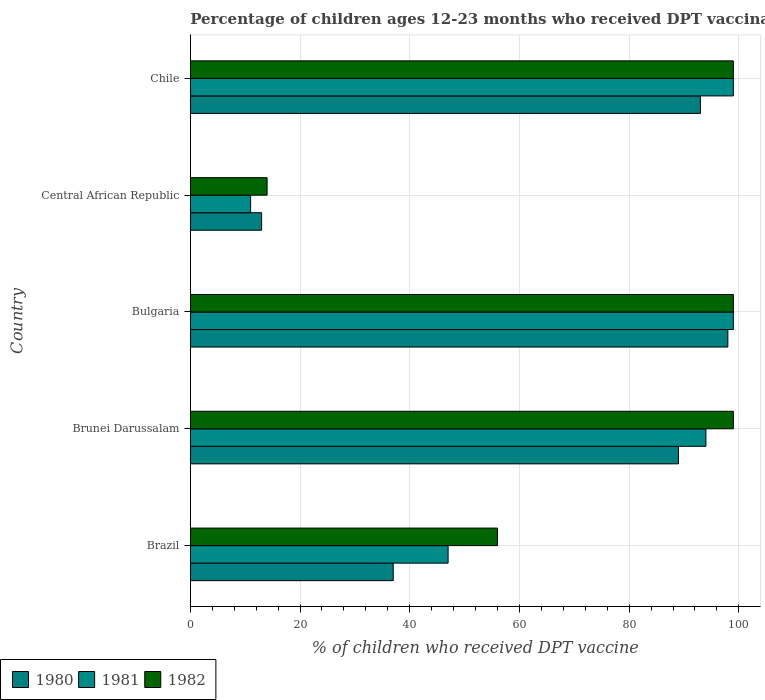How many groups of bars are there?
Give a very brief answer. 5. Are the number of bars per tick equal to the number of legend labels?
Ensure brevity in your answer.  Yes. Are the number of bars on each tick of the Y-axis equal?
Provide a succinct answer. Yes. What is the label of the 3rd group of bars from the top?
Your answer should be compact. Bulgaria. In how many cases, is the number of bars for a given country not equal to the number of legend labels?
Your answer should be very brief. 0. Across all countries, what is the maximum percentage of children who received DPT vaccination in 1981?
Offer a very short reply. 99. Across all countries, what is the minimum percentage of children who received DPT vaccination in 1980?
Keep it short and to the point. 13. In which country was the percentage of children who received DPT vaccination in 1981 minimum?
Offer a terse response. Central African Republic. What is the total percentage of children who received DPT vaccination in 1980 in the graph?
Make the answer very short. 330. What is the difference between the percentage of children who received DPT vaccination in 1982 in Brazil and that in Chile?
Give a very brief answer. -43. What is the average percentage of children who received DPT vaccination in 1981 per country?
Offer a very short reply. 70. Is the difference between the percentage of children who received DPT vaccination in 1982 in Bulgaria and Central African Republic greater than the difference between the percentage of children who received DPT vaccination in 1981 in Bulgaria and Central African Republic?
Your response must be concise. No. What does the 3rd bar from the top in Chile represents?
Provide a succinct answer. 1980. What does the 1st bar from the bottom in Bulgaria represents?
Your answer should be compact. 1980. Is it the case that in every country, the sum of the percentage of children who received DPT vaccination in 1982 and percentage of children who received DPT vaccination in 1981 is greater than the percentage of children who received DPT vaccination in 1980?
Ensure brevity in your answer.  Yes. Where does the legend appear in the graph?
Your answer should be compact. Bottom left. What is the title of the graph?
Your answer should be compact. Percentage of children ages 12-23 months who received DPT vaccinations. What is the label or title of the X-axis?
Give a very brief answer. % of children who received DPT vaccine. What is the label or title of the Y-axis?
Your answer should be compact. Country. What is the % of children who received DPT vaccine in 1980 in Brazil?
Offer a terse response. 37. What is the % of children who received DPT vaccine of 1981 in Brazil?
Give a very brief answer. 47. What is the % of children who received DPT vaccine of 1982 in Brazil?
Your answer should be compact. 56. What is the % of children who received DPT vaccine of 1980 in Brunei Darussalam?
Make the answer very short. 89. What is the % of children who received DPT vaccine in 1981 in Brunei Darussalam?
Give a very brief answer. 94. What is the % of children who received DPT vaccine in 1982 in Brunei Darussalam?
Ensure brevity in your answer.  99. What is the % of children who received DPT vaccine of 1980 in Bulgaria?
Offer a very short reply. 98. What is the % of children who received DPT vaccine of 1981 in Bulgaria?
Provide a succinct answer. 99. What is the % of children who received DPT vaccine in 1980 in Central African Republic?
Provide a short and direct response. 13. What is the % of children who received DPT vaccine of 1981 in Central African Republic?
Offer a very short reply. 11. What is the % of children who received DPT vaccine of 1980 in Chile?
Provide a succinct answer. 93. What is the % of children who received DPT vaccine in 1981 in Chile?
Your answer should be compact. 99. Across all countries, what is the maximum % of children who received DPT vaccine in 1981?
Offer a very short reply. 99. Across all countries, what is the minimum % of children who received DPT vaccine in 1980?
Your answer should be compact. 13. What is the total % of children who received DPT vaccine of 1980 in the graph?
Provide a succinct answer. 330. What is the total % of children who received DPT vaccine of 1981 in the graph?
Provide a short and direct response. 350. What is the total % of children who received DPT vaccine of 1982 in the graph?
Ensure brevity in your answer.  367. What is the difference between the % of children who received DPT vaccine of 1980 in Brazil and that in Brunei Darussalam?
Offer a terse response. -52. What is the difference between the % of children who received DPT vaccine in 1981 in Brazil and that in Brunei Darussalam?
Give a very brief answer. -47. What is the difference between the % of children who received DPT vaccine in 1982 in Brazil and that in Brunei Darussalam?
Keep it short and to the point. -43. What is the difference between the % of children who received DPT vaccine in 1980 in Brazil and that in Bulgaria?
Ensure brevity in your answer.  -61. What is the difference between the % of children who received DPT vaccine in 1981 in Brazil and that in Bulgaria?
Make the answer very short. -52. What is the difference between the % of children who received DPT vaccine of 1982 in Brazil and that in Bulgaria?
Keep it short and to the point. -43. What is the difference between the % of children who received DPT vaccine of 1980 in Brazil and that in Central African Republic?
Make the answer very short. 24. What is the difference between the % of children who received DPT vaccine of 1980 in Brazil and that in Chile?
Provide a short and direct response. -56. What is the difference between the % of children who received DPT vaccine of 1981 in Brazil and that in Chile?
Your response must be concise. -52. What is the difference between the % of children who received DPT vaccine of 1982 in Brazil and that in Chile?
Provide a succinct answer. -43. What is the difference between the % of children who received DPT vaccine in 1981 in Brunei Darussalam and that in Bulgaria?
Your answer should be very brief. -5. What is the difference between the % of children who received DPT vaccine of 1982 in Brunei Darussalam and that in Central African Republic?
Ensure brevity in your answer.  85. What is the difference between the % of children who received DPT vaccine of 1981 in Brunei Darussalam and that in Chile?
Ensure brevity in your answer.  -5. What is the difference between the % of children who received DPT vaccine in 1982 in Brunei Darussalam and that in Chile?
Your answer should be compact. 0. What is the difference between the % of children who received DPT vaccine in 1980 in Bulgaria and that in Central African Republic?
Your answer should be very brief. 85. What is the difference between the % of children who received DPT vaccine in 1981 in Bulgaria and that in Central African Republic?
Ensure brevity in your answer.  88. What is the difference between the % of children who received DPT vaccine of 1982 in Bulgaria and that in Central African Republic?
Offer a very short reply. 85. What is the difference between the % of children who received DPT vaccine in 1980 in Bulgaria and that in Chile?
Provide a succinct answer. 5. What is the difference between the % of children who received DPT vaccine in 1980 in Central African Republic and that in Chile?
Your answer should be very brief. -80. What is the difference between the % of children who received DPT vaccine in 1981 in Central African Republic and that in Chile?
Your answer should be very brief. -88. What is the difference between the % of children who received DPT vaccine in 1982 in Central African Republic and that in Chile?
Give a very brief answer. -85. What is the difference between the % of children who received DPT vaccine in 1980 in Brazil and the % of children who received DPT vaccine in 1981 in Brunei Darussalam?
Give a very brief answer. -57. What is the difference between the % of children who received DPT vaccine of 1980 in Brazil and the % of children who received DPT vaccine of 1982 in Brunei Darussalam?
Provide a succinct answer. -62. What is the difference between the % of children who received DPT vaccine in 1981 in Brazil and the % of children who received DPT vaccine in 1982 in Brunei Darussalam?
Give a very brief answer. -52. What is the difference between the % of children who received DPT vaccine of 1980 in Brazil and the % of children who received DPT vaccine of 1981 in Bulgaria?
Give a very brief answer. -62. What is the difference between the % of children who received DPT vaccine of 1980 in Brazil and the % of children who received DPT vaccine of 1982 in Bulgaria?
Your response must be concise. -62. What is the difference between the % of children who received DPT vaccine in 1981 in Brazil and the % of children who received DPT vaccine in 1982 in Bulgaria?
Offer a very short reply. -52. What is the difference between the % of children who received DPT vaccine in 1980 in Brazil and the % of children who received DPT vaccine in 1981 in Chile?
Offer a terse response. -62. What is the difference between the % of children who received DPT vaccine in 1980 in Brazil and the % of children who received DPT vaccine in 1982 in Chile?
Offer a terse response. -62. What is the difference between the % of children who received DPT vaccine in 1981 in Brazil and the % of children who received DPT vaccine in 1982 in Chile?
Offer a very short reply. -52. What is the difference between the % of children who received DPT vaccine of 1981 in Brunei Darussalam and the % of children who received DPT vaccine of 1982 in Bulgaria?
Give a very brief answer. -5. What is the difference between the % of children who received DPT vaccine of 1981 in Brunei Darussalam and the % of children who received DPT vaccine of 1982 in Central African Republic?
Make the answer very short. 80. What is the difference between the % of children who received DPT vaccine of 1980 in Brunei Darussalam and the % of children who received DPT vaccine of 1981 in Chile?
Offer a terse response. -10. What is the difference between the % of children who received DPT vaccine in 1980 in Brunei Darussalam and the % of children who received DPT vaccine in 1982 in Chile?
Your answer should be compact. -10. What is the difference between the % of children who received DPT vaccine in 1981 in Brunei Darussalam and the % of children who received DPT vaccine in 1982 in Chile?
Your answer should be compact. -5. What is the difference between the % of children who received DPT vaccine in 1980 in Bulgaria and the % of children who received DPT vaccine in 1981 in Central African Republic?
Make the answer very short. 87. What is the difference between the % of children who received DPT vaccine of 1980 in Bulgaria and the % of children who received DPT vaccine of 1982 in Central African Republic?
Offer a very short reply. 84. What is the difference between the % of children who received DPT vaccine of 1981 in Bulgaria and the % of children who received DPT vaccine of 1982 in Central African Republic?
Your response must be concise. 85. What is the difference between the % of children who received DPT vaccine of 1981 in Bulgaria and the % of children who received DPT vaccine of 1982 in Chile?
Provide a short and direct response. 0. What is the difference between the % of children who received DPT vaccine in 1980 in Central African Republic and the % of children who received DPT vaccine in 1981 in Chile?
Offer a very short reply. -86. What is the difference between the % of children who received DPT vaccine in 1980 in Central African Republic and the % of children who received DPT vaccine in 1982 in Chile?
Ensure brevity in your answer.  -86. What is the difference between the % of children who received DPT vaccine of 1981 in Central African Republic and the % of children who received DPT vaccine of 1982 in Chile?
Provide a short and direct response. -88. What is the average % of children who received DPT vaccine of 1980 per country?
Make the answer very short. 66. What is the average % of children who received DPT vaccine in 1981 per country?
Your answer should be compact. 70. What is the average % of children who received DPT vaccine in 1982 per country?
Ensure brevity in your answer.  73.4. What is the difference between the % of children who received DPT vaccine of 1980 and % of children who received DPT vaccine of 1981 in Brazil?
Give a very brief answer. -10. What is the difference between the % of children who received DPT vaccine of 1980 and % of children who received DPT vaccine of 1982 in Brazil?
Make the answer very short. -19. What is the difference between the % of children who received DPT vaccine of 1980 and % of children who received DPT vaccine of 1982 in Brunei Darussalam?
Keep it short and to the point. -10. What is the difference between the % of children who received DPT vaccine in 1981 and % of children who received DPT vaccine in 1982 in Brunei Darussalam?
Make the answer very short. -5. What is the difference between the % of children who received DPT vaccine in 1981 and % of children who received DPT vaccine in 1982 in Bulgaria?
Ensure brevity in your answer.  0. What is the difference between the % of children who received DPT vaccine in 1980 and % of children who received DPT vaccine in 1981 in Central African Republic?
Offer a very short reply. 2. What is the difference between the % of children who received DPT vaccine in 1980 and % of children who received DPT vaccine in 1982 in Chile?
Make the answer very short. -6. What is the ratio of the % of children who received DPT vaccine of 1980 in Brazil to that in Brunei Darussalam?
Offer a terse response. 0.42. What is the ratio of the % of children who received DPT vaccine of 1982 in Brazil to that in Brunei Darussalam?
Give a very brief answer. 0.57. What is the ratio of the % of children who received DPT vaccine in 1980 in Brazil to that in Bulgaria?
Ensure brevity in your answer.  0.38. What is the ratio of the % of children who received DPT vaccine of 1981 in Brazil to that in Bulgaria?
Offer a terse response. 0.47. What is the ratio of the % of children who received DPT vaccine of 1982 in Brazil to that in Bulgaria?
Offer a terse response. 0.57. What is the ratio of the % of children who received DPT vaccine in 1980 in Brazil to that in Central African Republic?
Provide a short and direct response. 2.85. What is the ratio of the % of children who received DPT vaccine in 1981 in Brazil to that in Central African Republic?
Provide a succinct answer. 4.27. What is the ratio of the % of children who received DPT vaccine in 1982 in Brazil to that in Central African Republic?
Provide a succinct answer. 4. What is the ratio of the % of children who received DPT vaccine in 1980 in Brazil to that in Chile?
Keep it short and to the point. 0.4. What is the ratio of the % of children who received DPT vaccine of 1981 in Brazil to that in Chile?
Provide a succinct answer. 0.47. What is the ratio of the % of children who received DPT vaccine in 1982 in Brazil to that in Chile?
Give a very brief answer. 0.57. What is the ratio of the % of children who received DPT vaccine of 1980 in Brunei Darussalam to that in Bulgaria?
Ensure brevity in your answer.  0.91. What is the ratio of the % of children who received DPT vaccine in 1981 in Brunei Darussalam to that in Bulgaria?
Your answer should be compact. 0.95. What is the ratio of the % of children who received DPT vaccine of 1980 in Brunei Darussalam to that in Central African Republic?
Your answer should be very brief. 6.85. What is the ratio of the % of children who received DPT vaccine in 1981 in Brunei Darussalam to that in Central African Republic?
Make the answer very short. 8.55. What is the ratio of the % of children who received DPT vaccine in 1982 in Brunei Darussalam to that in Central African Republic?
Give a very brief answer. 7.07. What is the ratio of the % of children who received DPT vaccine in 1980 in Brunei Darussalam to that in Chile?
Give a very brief answer. 0.96. What is the ratio of the % of children who received DPT vaccine of 1981 in Brunei Darussalam to that in Chile?
Your answer should be compact. 0.95. What is the ratio of the % of children who received DPT vaccine of 1980 in Bulgaria to that in Central African Republic?
Offer a very short reply. 7.54. What is the ratio of the % of children who received DPT vaccine in 1981 in Bulgaria to that in Central African Republic?
Keep it short and to the point. 9. What is the ratio of the % of children who received DPT vaccine of 1982 in Bulgaria to that in Central African Republic?
Your answer should be compact. 7.07. What is the ratio of the % of children who received DPT vaccine in 1980 in Bulgaria to that in Chile?
Give a very brief answer. 1.05. What is the ratio of the % of children who received DPT vaccine of 1982 in Bulgaria to that in Chile?
Your response must be concise. 1. What is the ratio of the % of children who received DPT vaccine of 1980 in Central African Republic to that in Chile?
Offer a terse response. 0.14. What is the ratio of the % of children who received DPT vaccine in 1982 in Central African Republic to that in Chile?
Give a very brief answer. 0.14. What is the difference between the highest and the second highest % of children who received DPT vaccine of 1980?
Give a very brief answer. 5. What is the difference between the highest and the second highest % of children who received DPT vaccine in 1981?
Make the answer very short. 0. What is the difference between the highest and the second highest % of children who received DPT vaccine of 1982?
Give a very brief answer. 0. What is the difference between the highest and the lowest % of children who received DPT vaccine of 1980?
Provide a short and direct response. 85. 